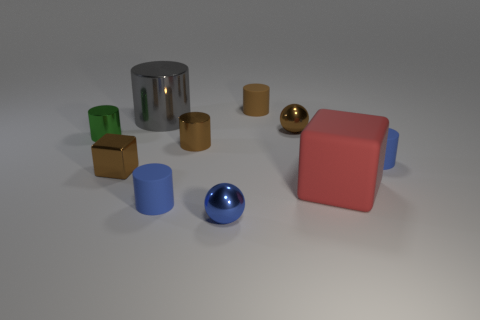Subtract all small cylinders. How many cylinders are left? 1 Subtract all red spheres. How many blue cylinders are left? 2 Subtract all gray cylinders. How many cylinders are left? 5 Subtract all cylinders. How many objects are left? 4 Subtract all green blocks. Subtract all purple balls. How many blocks are left? 2 Subtract all small blue matte blocks. Subtract all green things. How many objects are left? 9 Add 6 matte cylinders. How many matte cylinders are left? 9 Add 2 large red rubber spheres. How many large red rubber spheres exist? 2 Subtract 1 brown cylinders. How many objects are left? 9 